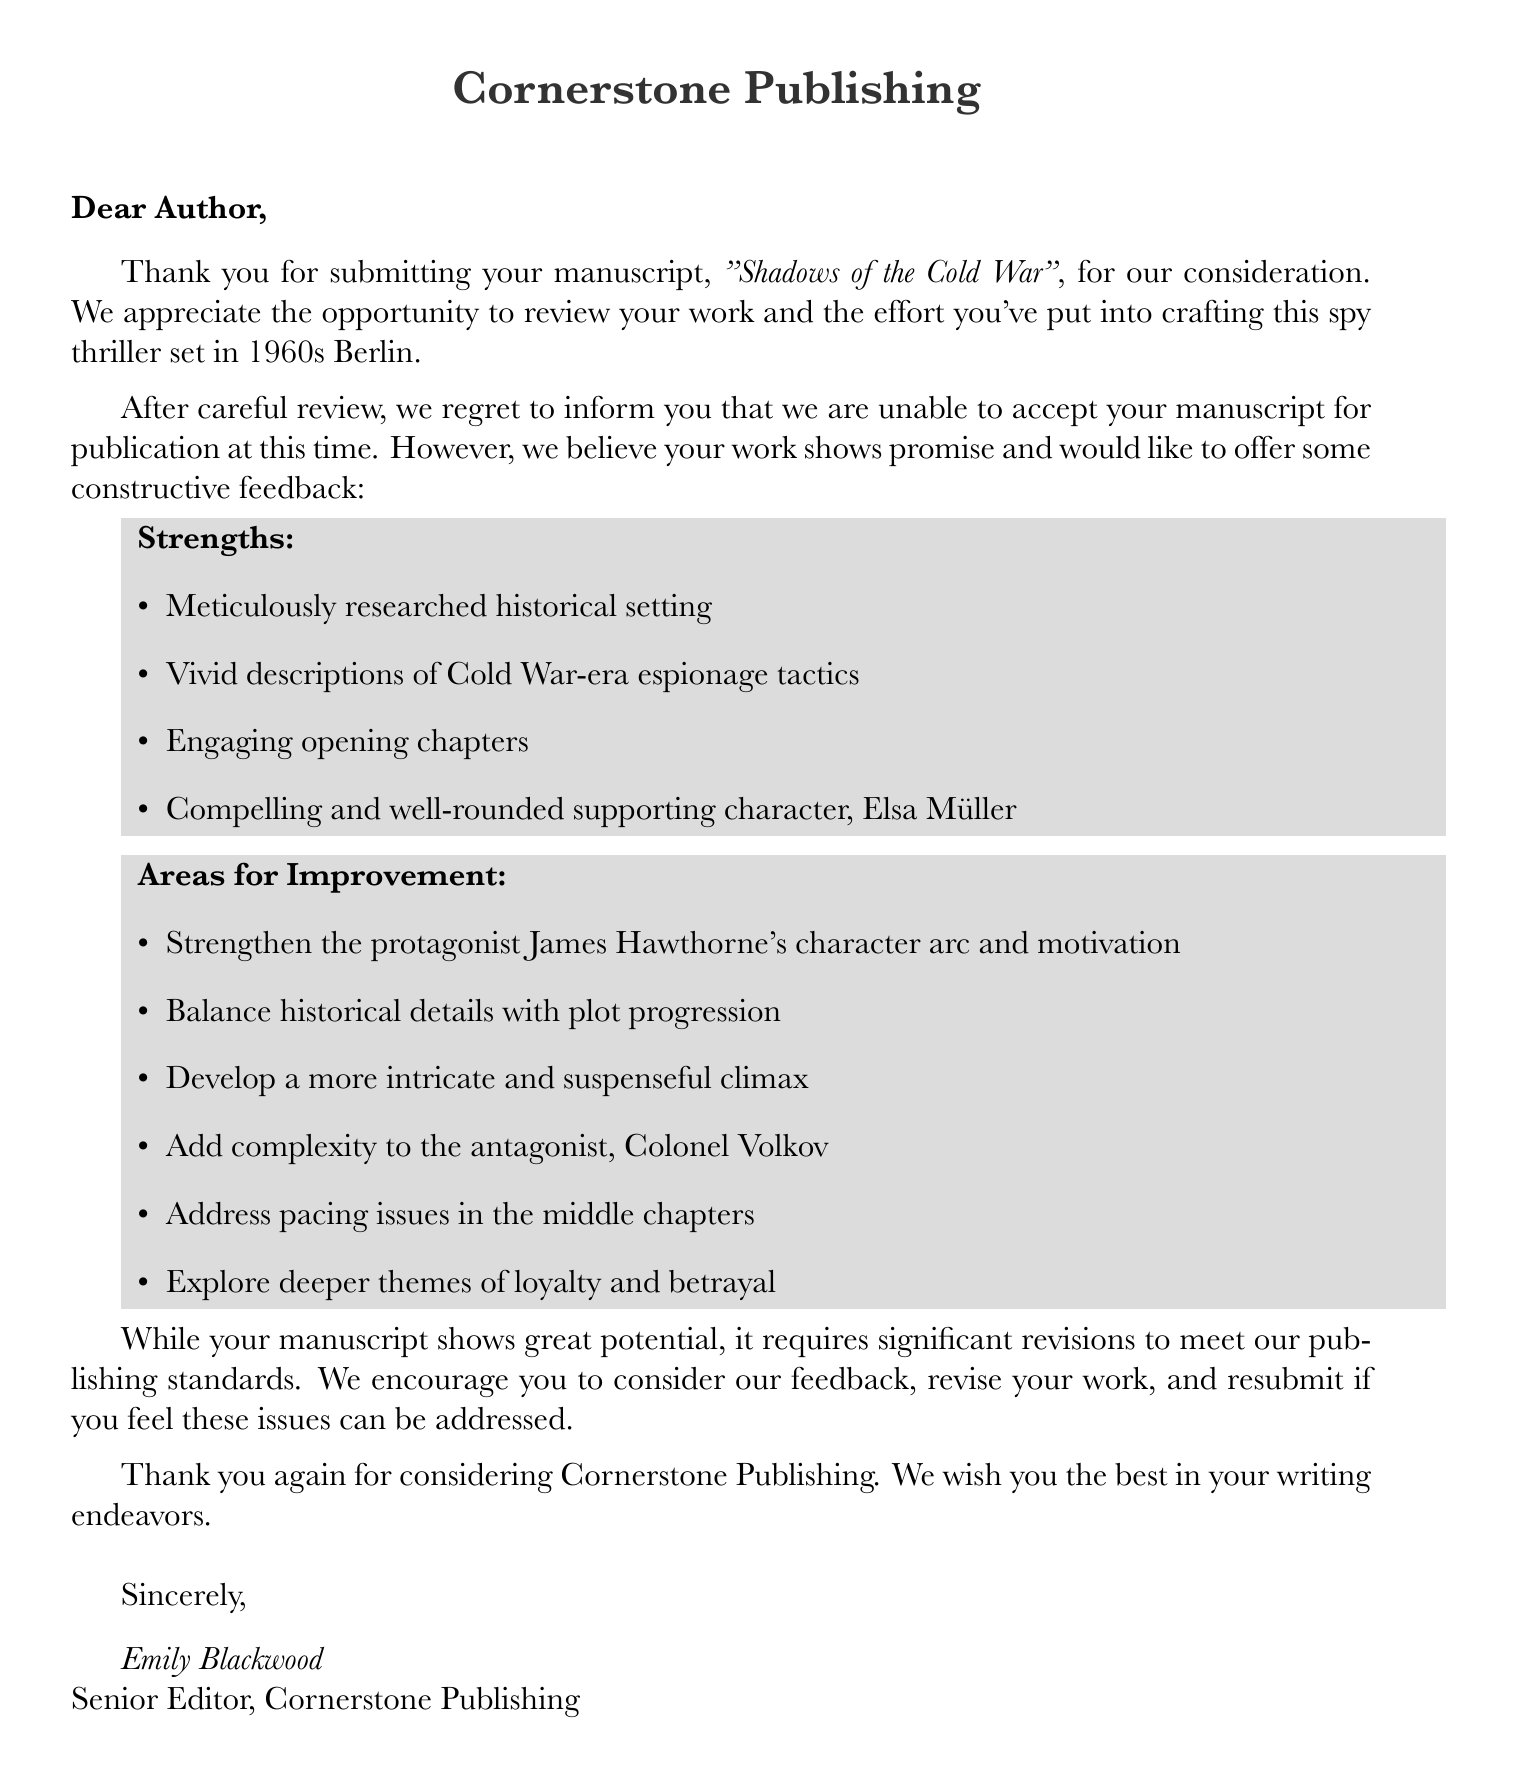What is the name of the publishing house? The document specifies that the publishing house is Cornerstone Publishing.
Answer: Cornerstone Publishing Who is the senior editor? The letter lists Emily Blackwood as the senior editor of Cornerstone Publishing.
Answer: Emily Blackwood What is the title of the manuscript? The title of the manuscript submitted for consideration is provided in the letter.
Answer: Shadows of the Cold War Which character is described as compelling and well-rounded? The feedback mentions the supporting character, Elsa Müller, as compelling and well-rounded.
Answer: Elsa Müller What is one area of improvement mentioned for the protagonist? The feedback indicates that the protagonist, James Hawthorne, lacks depth and clear motivation.
Answer: Depth and clear motivation How does the editor describe the pacing of the middle chapters? The editor notes there are pacing issues specifically in the middle chapters of the manuscript.
Answer: Pacing issues What aspect of the climax does the editor find lacking? The feedback states that the climax feels rushed and lacks tension.
Answer: Rushed and lacks tension What themes does the editor suggest to explore further? The letter encourages the exploration of deeper themes of loyalty and betrayal.
Answer: Loyalty and betrayal What is the overall conclusion given by the editor about the manuscript? The conclusion in the letter emphasizes that the manuscript shows promise but requires significant revisions.
Answer: Requires significant revisions 